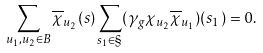Convert formula to latex. <formula><loc_0><loc_0><loc_500><loc_500>\sum _ { u _ { 1 } , u _ { 2 } \in B } \overline { \chi } _ { u _ { 2 } } ( s ) \sum _ { s _ { 1 } \in \S } ( \gamma _ { g } \chi _ { u _ { 2 } } \overline { \chi } _ { u _ { 1 } } ) ( s _ { 1 } ) = 0 .</formula> 